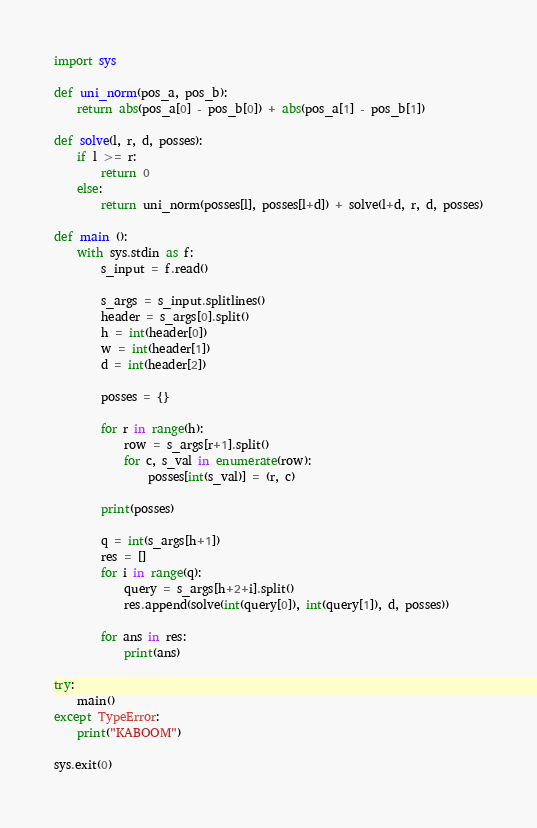<code> <loc_0><loc_0><loc_500><loc_500><_Python_>import sys

def uni_norm(pos_a, pos_b):
    return abs(pos_a[0] - pos_b[0]) + abs(pos_a[1] - pos_b[1])

def solve(l, r, d, posses):
    if l >= r:
        return 0
    else:
        return uni_norm(posses[l], posses[l+d]) + solve(l+d, r, d, posses)

def main ():
    with sys.stdin as f:
        s_input = f.read()

        s_args = s_input.splitlines()
        header = s_args[0].split()
        h = int(header[0])
        w = int(header[1])
        d = int(header[2])
        
        posses = {}
        
        for r in range(h):
            row = s_args[r+1].split()
            for c, s_val in enumerate(row):
                posses[int(s_val)] = (r, c)

        print(posses)

        q = int(s_args[h+1])
        res = []
        for i in range(q):
            query = s_args[h+2+i].split()
            res.append(solve(int(query[0]), int(query[1]), d, posses))

        for ans in res:
            print(ans)

try:
    main()
except TypeError:
    print("KABOOM")
    
sys.exit(0)
</code> 